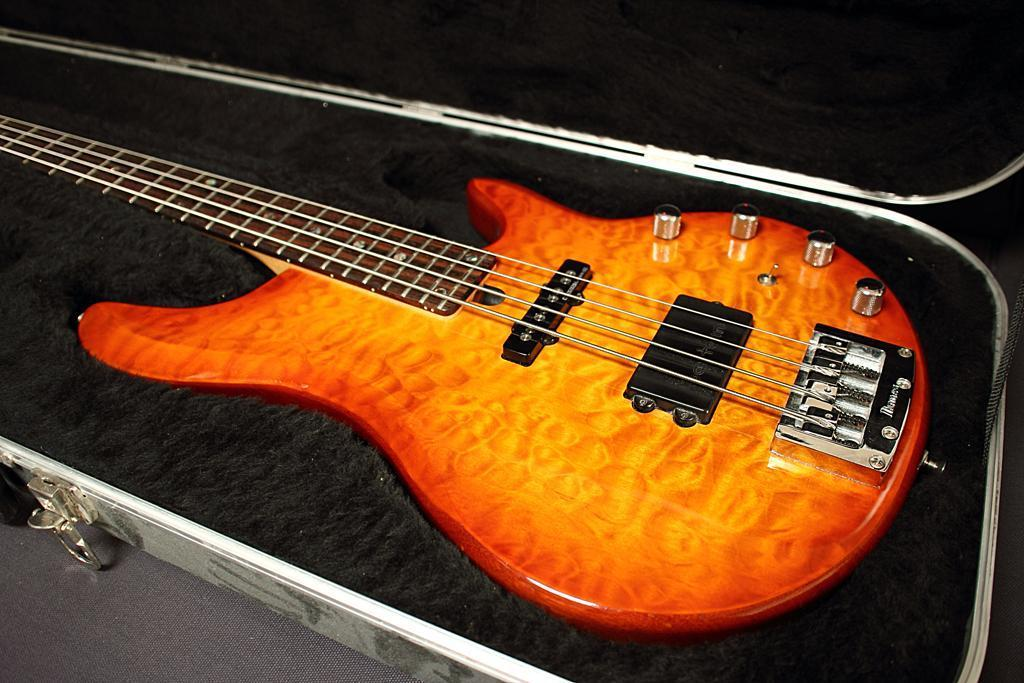What musical instrument is present in the image? There is a guitar in the image. What object can be seen on the floor in the image? There is a box on the floor in the image. How does the guitar breathe in the image? Guitars do not breathe, as they are inanimate objects. The question is not relevant to the image, as there is no mention of breathing or any living organisms in the provided facts. 